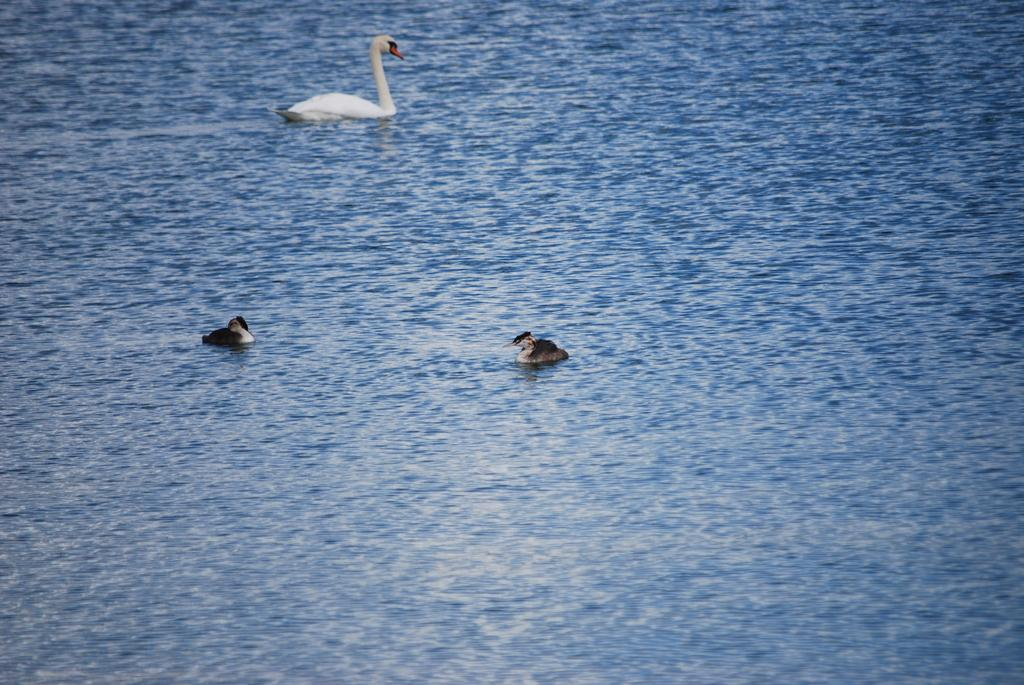What is visible in the image? Water is visible in the image. What type of animals can be seen in the image? Birds can be seen in the image. What colors are the birds in the image? The birds are white, black, and orange in color. Where are the cherries hanging in the image? There are no cherries present in the image. What type of dress is the bird wearing in the image? The birds in the image are not wearing any dresses, as they are actual birds and not human-like figures. 